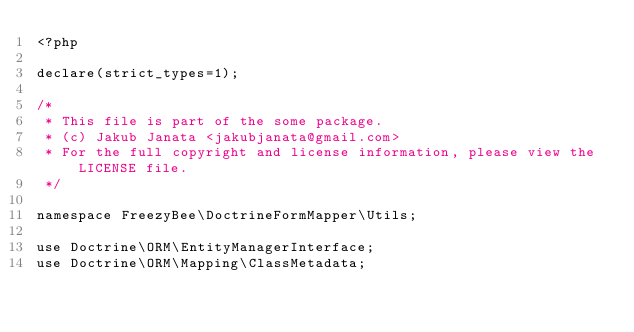Convert code to text. <code><loc_0><loc_0><loc_500><loc_500><_PHP_><?php

declare(strict_types=1);

/*
 * This file is part of the some package.
 * (c) Jakub Janata <jakubjanata@gmail.com>
 * For the full copyright and license information, please view the LICENSE file.
 */

namespace FreezyBee\DoctrineFormMapper\Utils;

use Doctrine\ORM\EntityManagerInterface;
use Doctrine\ORM\Mapping\ClassMetadata;</code> 